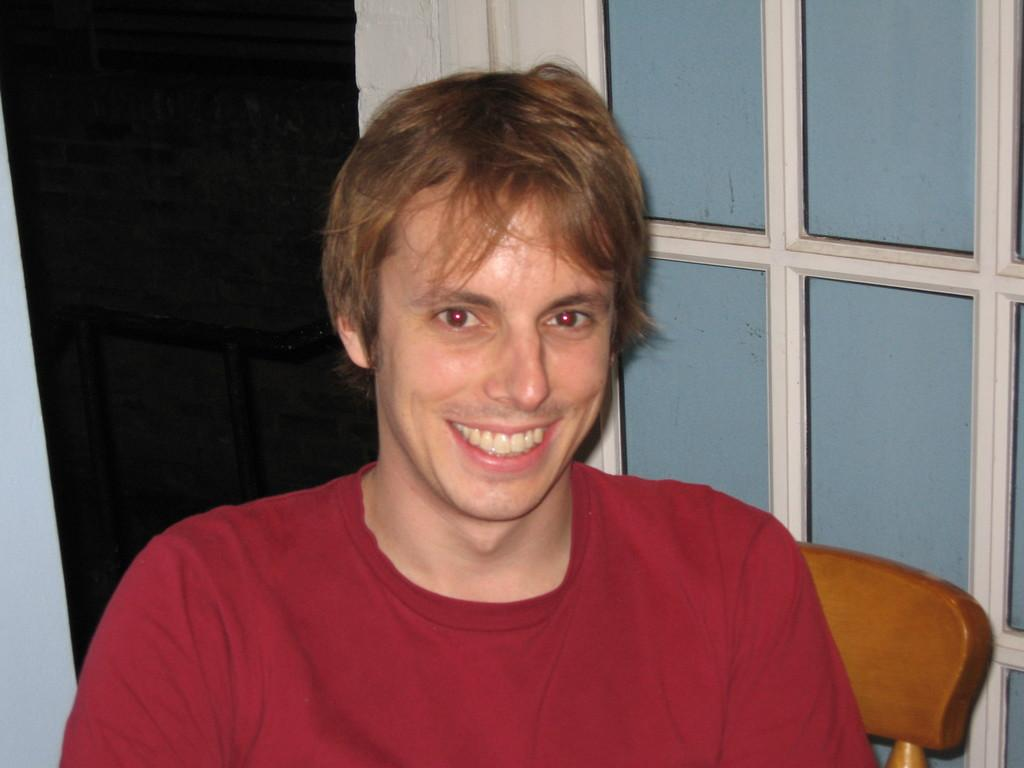Who is present in the image? There is a man in the image. What is the man doing in the image? The man is sitting on a wooden chair and smiling. What can be seen on the right side of the image? There is a glass window on the right side of the image. What type of duck can be seen in the image? There is no duck present in the image. What is the man's sense of humor like in the image? The image does not provide information about the man's sense of humor. 